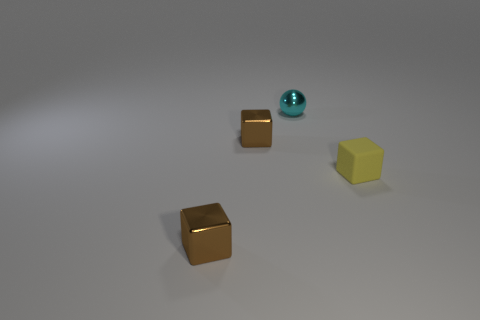What number of things are things left of the tiny matte object or small cyan matte cubes?
Offer a very short reply. 3. Are there any small gray metal things?
Ensure brevity in your answer.  No. There is a cyan object to the left of the small rubber object; what is its material?
Keep it short and to the point. Metal. What number of large things are green metal spheres or metal balls?
Your answer should be very brief. 0. What color is the sphere?
Your response must be concise. Cyan. There is a small block that is right of the small sphere; are there any cubes that are behind it?
Your answer should be very brief. Yes. Is the number of tiny blocks to the right of the sphere less than the number of big red cylinders?
Offer a terse response. No. Is the material of the tiny brown cube that is in front of the tiny yellow block the same as the yellow cube?
Your response must be concise. No. Is the number of tiny yellow matte objects behind the matte object less than the number of cyan shiny objects that are in front of the small cyan metallic thing?
Your response must be concise. No. There is a tiny metal thing in front of the yellow matte object; does it have the same color as the small object that is to the right of the tiny cyan metallic thing?
Make the answer very short. No. 